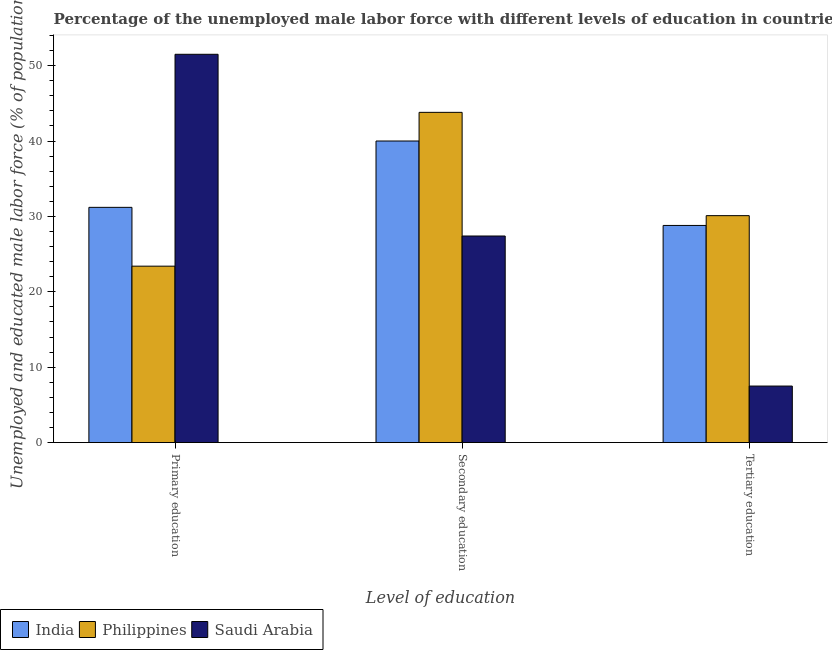How many groups of bars are there?
Your answer should be compact. 3. How many bars are there on the 2nd tick from the left?
Provide a short and direct response. 3. What is the label of the 3rd group of bars from the left?
Your response must be concise. Tertiary education. What is the percentage of male labor force who received primary education in Saudi Arabia?
Provide a short and direct response. 51.5. Across all countries, what is the maximum percentage of male labor force who received primary education?
Offer a terse response. 51.5. Across all countries, what is the minimum percentage of male labor force who received primary education?
Offer a very short reply. 23.4. In which country was the percentage of male labor force who received secondary education maximum?
Your answer should be compact. Philippines. In which country was the percentage of male labor force who received tertiary education minimum?
Offer a terse response. Saudi Arabia. What is the total percentage of male labor force who received secondary education in the graph?
Provide a succinct answer. 111.2. What is the difference between the percentage of male labor force who received primary education in Saudi Arabia and that in India?
Ensure brevity in your answer.  20.3. What is the difference between the percentage of male labor force who received tertiary education in India and the percentage of male labor force who received primary education in Philippines?
Your response must be concise. 5.4. What is the average percentage of male labor force who received primary education per country?
Give a very brief answer. 35.37. What is the difference between the percentage of male labor force who received primary education and percentage of male labor force who received tertiary education in Saudi Arabia?
Make the answer very short. 44. In how many countries, is the percentage of male labor force who received secondary education greater than 18 %?
Give a very brief answer. 3. What is the ratio of the percentage of male labor force who received secondary education in India to that in Saudi Arabia?
Your response must be concise. 1.46. What is the difference between the highest and the second highest percentage of male labor force who received secondary education?
Your answer should be very brief. 3.8. What is the difference between the highest and the lowest percentage of male labor force who received primary education?
Ensure brevity in your answer.  28.1. In how many countries, is the percentage of male labor force who received tertiary education greater than the average percentage of male labor force who received tertiary education taken over all countries?
Your answer should be compact. 2. Is the sum of the percentage of male labor force who received primary education in India and Philippines greater than the maximum percentage of male labor force who received tertiary education across all countries?
Offer a very short reply. Yes. Are all the bars in the graph horizontal?
Provide a short and direct response. No. How many countries are there in the graph?
Make the answer very short. 3. What is the difference between two consecutive major ticks on the Y-axis?
Your response must be concise. 10. Where does the legend appear in the graph?
Your answer should be very brief. Bottom left. How are the legend labels stacked?
Your answer should be very brief. Horizontal. What is the title of the graph?
Provide a short and direct response. Percentage of the unemployed male labor force with different levels of education in countries. Does "Jordan" appear as one of the legend labels in the graph?
Provide a short and direct response. No. What is the label or title of the X-axis?
Provide a short and direct response. Level of education. What is the label or title of the Y-axis?
Your answer should be very brief. Unemployed and educated male labor force (% of population). What is the Unemployed and educated male labor force (% of population) of India in Primary education?
Ensure brevity in your answer.  31.2. What is the Unemployed and educated male labor force (% of population) in Philippines in Primary education?
Your response must be concise. 23.4. What is the Unemployed and educated male labor force (% of population) of Saudi Arabia in Primary education?
Offer a terse response. 51.5. What is the Unemployed and educated male labor force (% of population) in Philippines in Secondary education?
Your answer should be compact. 43.8. What is the Unemployed and educated male labor force (% of population) of Saudi Arabia in Secondary education?
Keep it short and to the point. 27.4. What is the Unemployed and educated male labor force (% of population) of India in Tertiary education?
Provide a short and direct response. 28.8. What is the Unemployed and educated male labor force (% of population) of Philippines in Tertiary education?
Your answer should be compact. 30.1. Across all Level of education, what is the maximum Unemployed and educated male labor force (% of population) of India?
Keep it short and to the point. 40. Across all Level of education, what is the maximum Unemployed and educated male labor force (% of population) in Philippines?
Offer a terse response. 43.8. Across all Level of education, what is the maximum Unemployed and educated male labor force (% of population) of Saudi Arabia?
Your response must be concise. 51.5. Across all Level of education, what is the minimum Unemployed and educated male labor force (% of population) in India?
Your answer should be very brief. 28.8. Across all Level of education, what is the minimum Unemployed and educated male labor force (% of population) of Philippines?
Provide a succinct answer. 23.4. What is the total Unemployed and educated male labor force (% of population) in India in the graph?
Keep it short and to the point. 100. What is the total Unemployed and educated male labor force (% of population) in Philippines in the graph?
Provide a succinct answer. 97.3. What is the total Unemployed and educated male labor force (% of population) of Saudi Arabia in the graph?
Your answer should be very brief. 86.4. What is the difference between the Unemployed and educated male labor force (% of population) of Philippines in Primary education and that in Secondary education?
Provide a short and direct response. -20.4. What is the difference between the Unemployed and educated male labor force (% of population) in Saudi Arabia in Primary education and that in Secondary education?
Make the answer very short. 24.1. What is the difference between the Unemployed and educated male labor force (% of population) in India in Primary education and that in Tertiary education?
Give a very brief answer. 2.4. What is the difference between the Unemployed and educated male labor force (% of population) of Philippines in Primary education and that in Tertiary education?
Your response must be concise. -6.7. What is the difference between the Unemployed and educated male labor force (% of population) in Saudi Arabia in Primary education and that in Tertiary education?
Your answer should be compact. 44. What is the difference between the Unemployed and educated male labor force (% of population) in Saudi Arabia in Secondary education and that in Tertiary education?
Make the answer very short. 19.9. What is the difference between the Unemployed and educated male labor force (% of population) in India in Primary education and the Unemployed and educated male labor force (% of population) in Philippines in Secondary education?
Ensure brevity in your answer.  -12.6. What is the difference between the Unemployed and educated male labor force (% of population) of India in Primary education and the Unemployed and educated male labor force (% of population) of Saudi Arabia in Secondary education?
Provide a short and direct response. 3.8. What is the difference between the Unemployed and educated male labor force (% of population) in Philippines in Primary education and the Unemployed and educated male labor force (% of population) in Saudi Arabia in Secondary education?
Your response must be concise. -4. What is the difference between the Unemployed and educated male labor force (% of population) in India in Primary education and the Unemployed and educated male labor force (% of population) in Philippines in Tertiary education?
Ensure brevity in your answer.  1.1. What is the difference between the Unemployed and educated male labor force (% of population) of India in Primary education and the Unemployed and educated male labor force (% of population) of Saudi Arabia in Tertiary education?
Offer a very short reply. 23.7. What is the difference between the Unemployed and educated male labor force (% of population) in India in Secondary education and the Unemployed and educated male labor force (% of population) in Philippines in Tertiary education?
Ensure brevity in your answer.  9.9. What is the difference between the Unemployed and educated male labor force (% of population) of India in Secondary education and the Unemployed and educated male labor force (% of population) of Saudi Arabia in Tertiary education?
Ensure brevity in your answer.  32.5. What is the difference between the Unemployed and educated male labor force (% of population) in Philippines in Secondary education and the Unemployed and educated male labor force (% of population) in Saudi Arabia in Tertiary education?
Give a very brief answer. 36.3. What is the average Unemployed and educated male labor force (% of population) in India per Level of education?
Give a very brief answer. 33.33. What is the average Unemployed and educated male labor force (% of population) of Philippines per Level of education?
Provide a short and direct response. 32.43. What is the average Unemployed and educated male labor force (% of population) of Saudi Arabia per Level of education?
Offer a terse response. 28.8. What is the difference between the Unemployed and educated male labor force (% of population) in India and Unemployed and educated male labor force (% of population) in Philippines in Primary education?
Your answer should be very brief. 7.8. What is the difference between the Unemployed and educated male labor force (% of population) of India and Unemployed and educated male labor force (% of population) of Saudi Arabia in Primary education?
Make the answer very short. -20.3. What is the difference between the Unemployed and educated male labor force (% of population) in Philippines and Unemployed and educated male labor force (% of population) in Saudi Arabia in Primary education?
Provide a succinct answer. -28.1. What is the difference between the Unemployed and educated male labor force (% of population) in India and Unemployed and educated male labor force (% of population) in Saudi Arabia in Secondary education?
Keep it short and to the point. 12.6. What is the difference between the Unemployed and educated male labor force (% of population) in India and Unemployed and educated male labor force (% of population) in Philippines in Tertiary education?
Provide a succinct answer. -1.3. What is the difference between the Unemployed and educated male labor force (% of population) in India and Unemployed and educated male labor force (% of population) in Saudi Arabia in Tertiary education?
Your answer should be compact. 21.3. What is the difference between the Unemployed and educated male labor force (% of population) of Philippines and Unemployed and educated male labor force (% of population) of Saudi Arabia in Tertiary education?
Give a very brief answer. 22.6. What is the ratio of the Unemployed and educated male labor force (% of population) in India in Primary education to that in Secondary education?
Offer a very short reply. 0.78. What is the ratio of the Unemployed and educated male labor force (% of population) in Philippines in Primary education to that in Secondary education?
Offer a terse response. 0.53. What is the ratio of the Unemployed and educated male labor force (% of population) in Saudi Arabia in Primary education to that in Secondary education?
Your answer should be compact. 1.88. What is the ratio of the Unemployed and educated male labor force (% of population) in Philippines in Primary education to that in Tertiary education?
Keep it short and to the point. 0.78. What is the ratio of the Unemployed and educated male labor force (% of population) of Saudi Arabia in Primary education to that in Tertiary education?
Keep it short and to the point. 6.87. What is the ratio of the Unemployed and educated male labor force (% of population) of India in Secondary education to that in Tertiary education?
Make the answer very short. 1.39. What is the ratio of the Unemployed and educated male labor force (% of population) in Philippines in Secondary education to that in Tertiary education?
Your answer should be very brief. 1.46. What is the ratio of the Unemployed and educated male labor force (% of population) of Saudi Arabia in Secondary education to that in Tertiary education?
Ensure brevity in your answer.  3.65. What is the difference between the highest and the second highest Unemployed and educated male labor force (% of population) of Saudi Arabia?
Offer a terse response. 24.1. What is the difference between the highest and the lowest Unemployed and educated male labor force (% of population) in Philippines?
Keep it short and to the point. 20.4. What is the difference between the highest and the lowest Unemployed and educated male labor force (% of population) in Saudi Arabia?
Give a very brief answer. 44. 